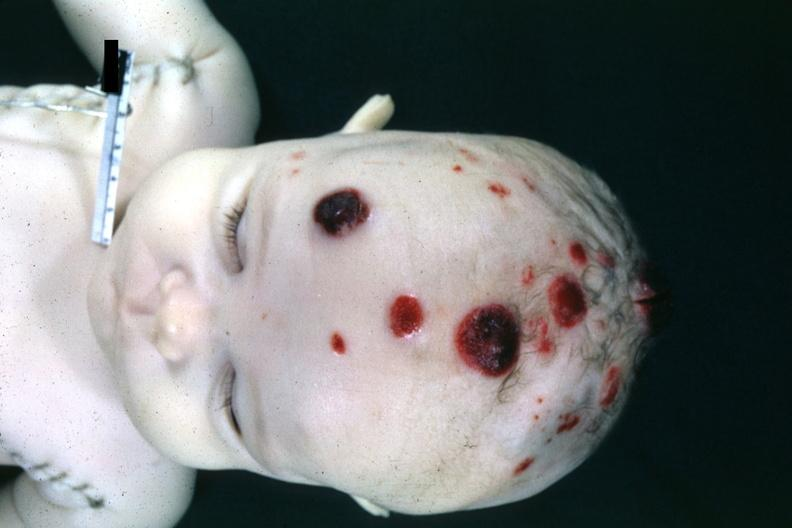where is this?
Answer the question using a single word or phrase. Skin 